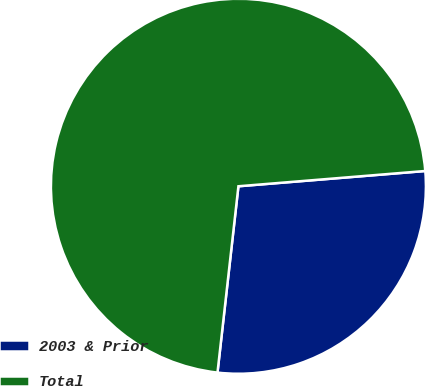<chart> <loc_0><loc_0><loc_500><loc_500><pie_chart><fcel>2003 & Prior<fcel>Total<nl><fcel>28.08%<fcel>71.92%<nl></chart> 